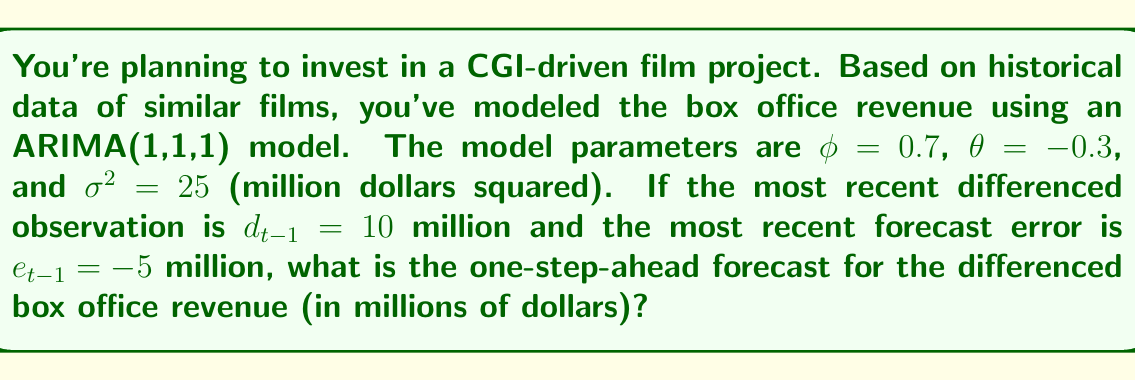Provide a solution to this math problem. Let's approach this step-by-step:

1) The ARIMA(1,1,1) model for the differenced series can be written as:

   $$d_t = \phi d_{t-1} + e_t - \theta e_{t-1}$$

   where $d_t$ is the differenced series, $e_t$ is the forecast error, and $\phi$ and $\theta$ are the model parameters.

2) We're given:
   - $\phi = 0.7$
   - $\theta = -0.3$
   - $d_{t-1} = 10$
   - $e_{t-1} = -5$

3) To make a one-step-ahead forecast, we set the future error term $e_t$ to its expected value, which is 0:

   $$\hat{d}_t = \phi d_{t-1} - \theta e_{t-1}$$

4) Now, let's substitute the values:

   $$\hat{d}_t = 0.7(10) - (-0.3)(-5)$$

5) Simplify:
   $$\hat{d}_t = 7 - 1.5 = 5.5$$

Therefore, the one-step-ahead forecast for the differenced box office revenue is 5.5 million dollars.
Answer: $5.5 million 